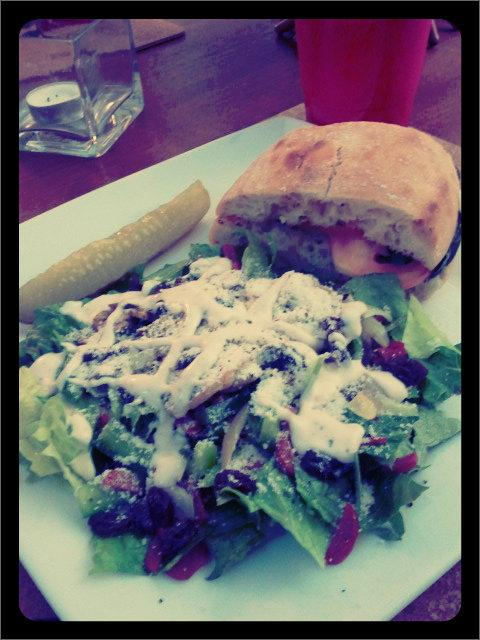What shape is the pickle cut in? spear 